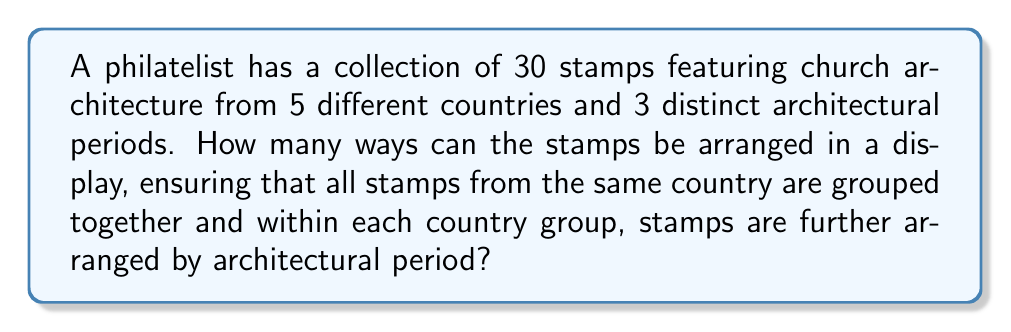What is the answer to this math problem? Let's approach this step-by-step:

1) First, we need to consider the arrangement of the countries. There are 5 countries, so there are 5! ways to arrange the country groups.

2) Within each country group, we need to arrange the architectural periods. There are 3! ways to arrange the periods for each country.

3) Since we need to arrange the periods for each of the 5 countries, we multiply 3! by itself 5 times: $(3!)^5$

4) Now, we need to consider the arrangement of stamps within each period of each country. However, we don't know how many stamps are in each period of each country. This doesn't matter because regardless of the number, the stamps within each period are already in a fixed order (as we're only arranging by country and period, not individual stamps within a period).

5) Therefore, the total number of permutations is the product of the number of ways to arrange the countries and the number of ways to arrange the periods within each country:

   $$5! \times (3!)^5$$

6) Let's calculate this:
   $$5! \times (3!)^5 = 120 \times 6^5 = 120 \times 7776 = 933,120$$
Answer: There are 933,120 ways to arrange the stamps. 